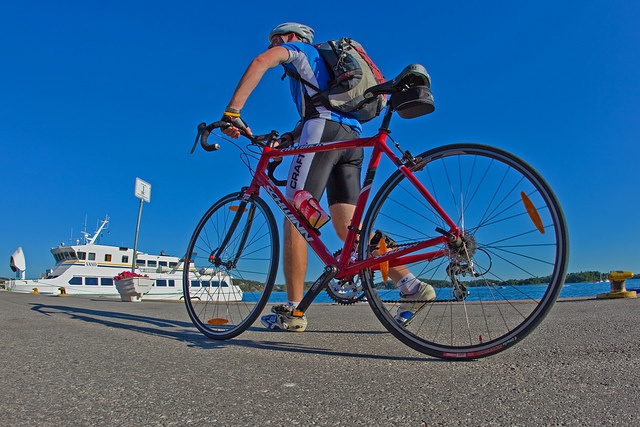Describe the objects in this image and their specific colors. I can see bicycle in blue, black, and gray tones, people in blue, black, gray, salmon, and navy tones, boat in blue, lightgray, darkgray, gray, and navy tones, backpack in blue, black, gray, darkgray, and navy tones, and bottle in blue, brown, and gray tones in this image. 